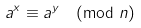Convert formula to latex. <formula><loc_0><loc_0><loc_500><loc_500>a ^ { x } \equiv a ^ { y } { \pmod { n } }</formula> 